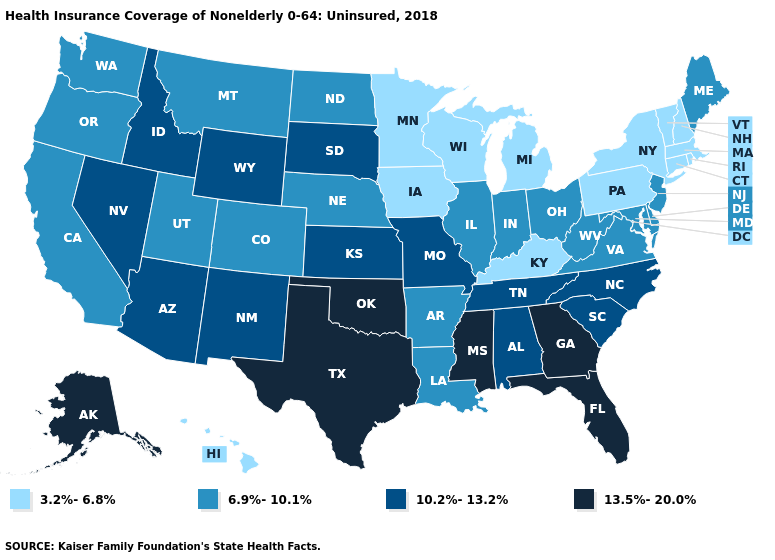Does New Mexico have a higher value than Missouri?
Write a very short answer. No. What is the value of Maryland?
Be succinct. 6.9%-10.1%. How many symbols are there in the legend?
Keep it brief. 4. Name the states that have a value in the range 13.5%-20.0%?
Keep it brief. Alaska, Florida, Georgia, Mississippi, Oklahoma, Texas. How many symbols are there in the legend?
Concise answer only. 4. What is the lowest value in states that border West Virginia?
Keep it brief. 3.2%-6.8%. Does the first symbol in the legend represent the smallest category?
Answer briefly. Yes. Name the states that have a value in the range 3.2%-6.8%?
Be succinct. Connecticut, Hawaii, Iowa, Kentucky, Massachusetts, Michigan, Minnesota, New Hampshire, New York, Pennsylvania, Rhode Island, Vermont, Wisconsin. What is the lowest value in the West?
Quick response, please. 3.2%-6.8%. Does West Virginia have a higher value than Louisiana?
Concise answer only. No. Does Kentucky have the lowest value in the USA?
Write a very short answer. Yes. Among the states that border Connecticut , which have the lowest value?
Write a very short answer. Massachusetts, New York, Rhode Island. How many symbols are there in the legend?
Keep it brief. 4. What is the value of Alaska?
Be succinct. 13.5%-20.0%. 